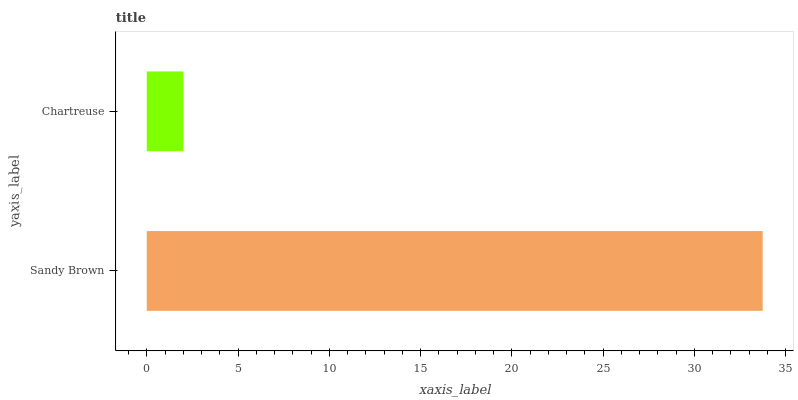Is Chartreuse the minimum?
Answer yes or no. Yes. Is Sandy Brown the maximum?
Answer yes or no. Yes. Is Chartreuse the maximum?
Answer yes or no. No. Is Sandy Brown greater than Chartreuse?
Answer yes or no. Yes. Is Chartreuse less than Sandy Brown?
Answer yes or no. Yes. Is Chartreuse greater than Sandy Brown?
Answer yes or no. No. Is Sandy Brown less than Chartreuse?
Answer yes or no. No. Is Sandy Brown the high median?
Answer yes or no. Yes. Is Chartreuse the low median?
Answer yes or no. Yes. Is Chartreuse the high median?
Answer yes or no. No. Is Sandy Brown the low median?
Answer yes or no. No. 